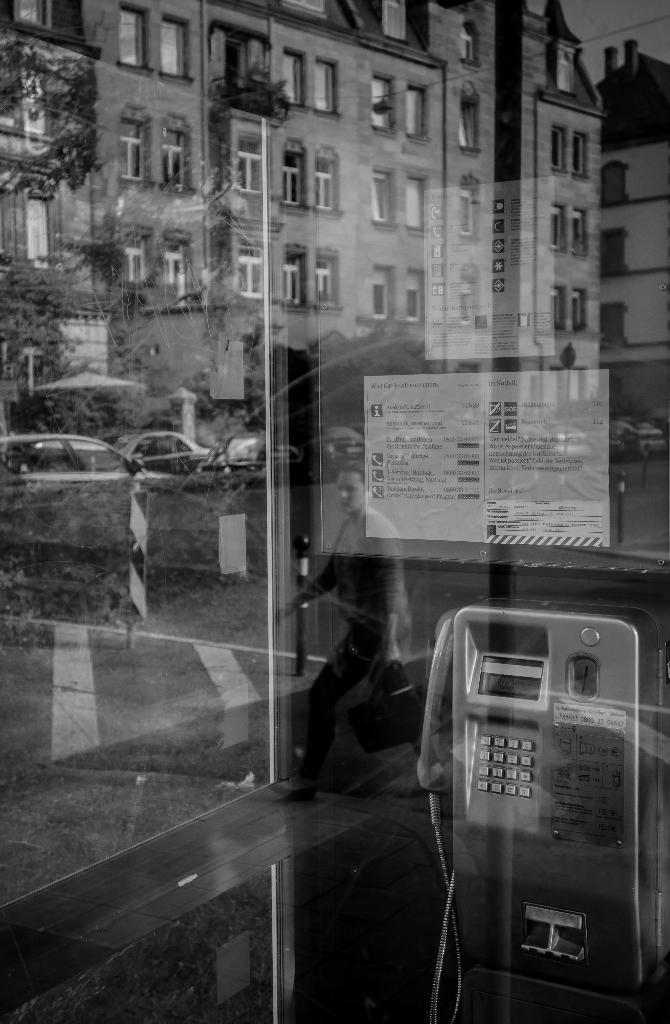What is the color scheme of the image? The image is black and white. What type of structure can be seen in the image? There is a public telephone booth in the image. What else can be seen in the image besides the telephone booth? There are buildings, windows, trees, motor vehicles on the road, and the sky visible in the image. How many chickens are sitting on the telephone booth in the image? There are no chickens present in the image; it features a public telephone booth and other elements mentioned earlier. What type of nerve is visible in the image? There is no nerve visible in the image; it is a black and white photograph of a public telephone booth and its surroundings. 